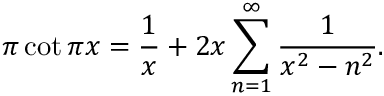Convert formula to latex. <formula><loc_0><loc_0><loc_500><loc_500>\pi \cot \pi x = { \frac { 1 } { x } } + 2 x \sum _ { n = 1 } ^ { \infty } { \frac { 1 } { x ^ { 2 } - n ^ { 2 } } } .</formula> 